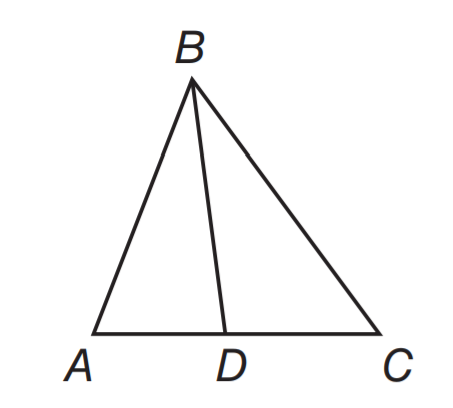Question: In \triangle A B C, B D is a median. If A D = 3 x + 5 and C D = 5 x - 1, find A C.
Choices:
A. 6
B. 12
C. 14
D. 28
Answer with the letter. Answer: D 